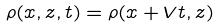Convert formula to latex. <formula><loc_0><loc_0><loc_500><loc_500>\rho ( x , z , t ) = \rho ( x + V t , z )</formula> 